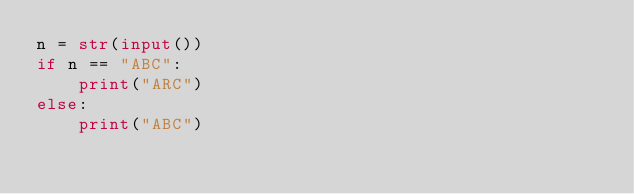<code> <loc_0><loc_0><loc_500><loc_500><_Python_>n = str(input())
if n == "ABC":
    print("ARC")
else:
    print("ABC")
</code> 